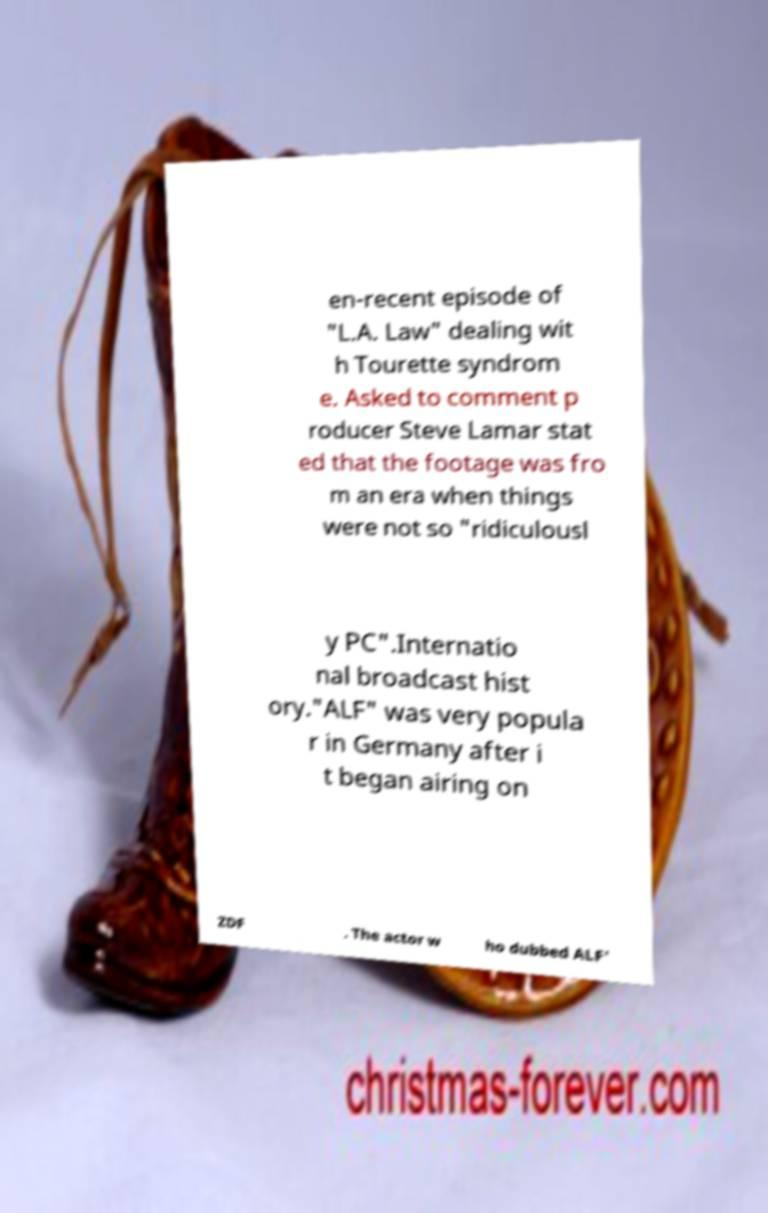Could you extract and type out the text from this image? en-recent episode of "L.A. Law" dealing wit h Tourette syndrom e. Asked to comment p roducer Steve Lamar stat ed that the footage was fro m an era when things were not so "ridiculousl y PC".Internatio nal broadcast hist ory."ALF" was very popula r in Germany after i t began airing on ZDF . The actor w ho dubbed ALF' 